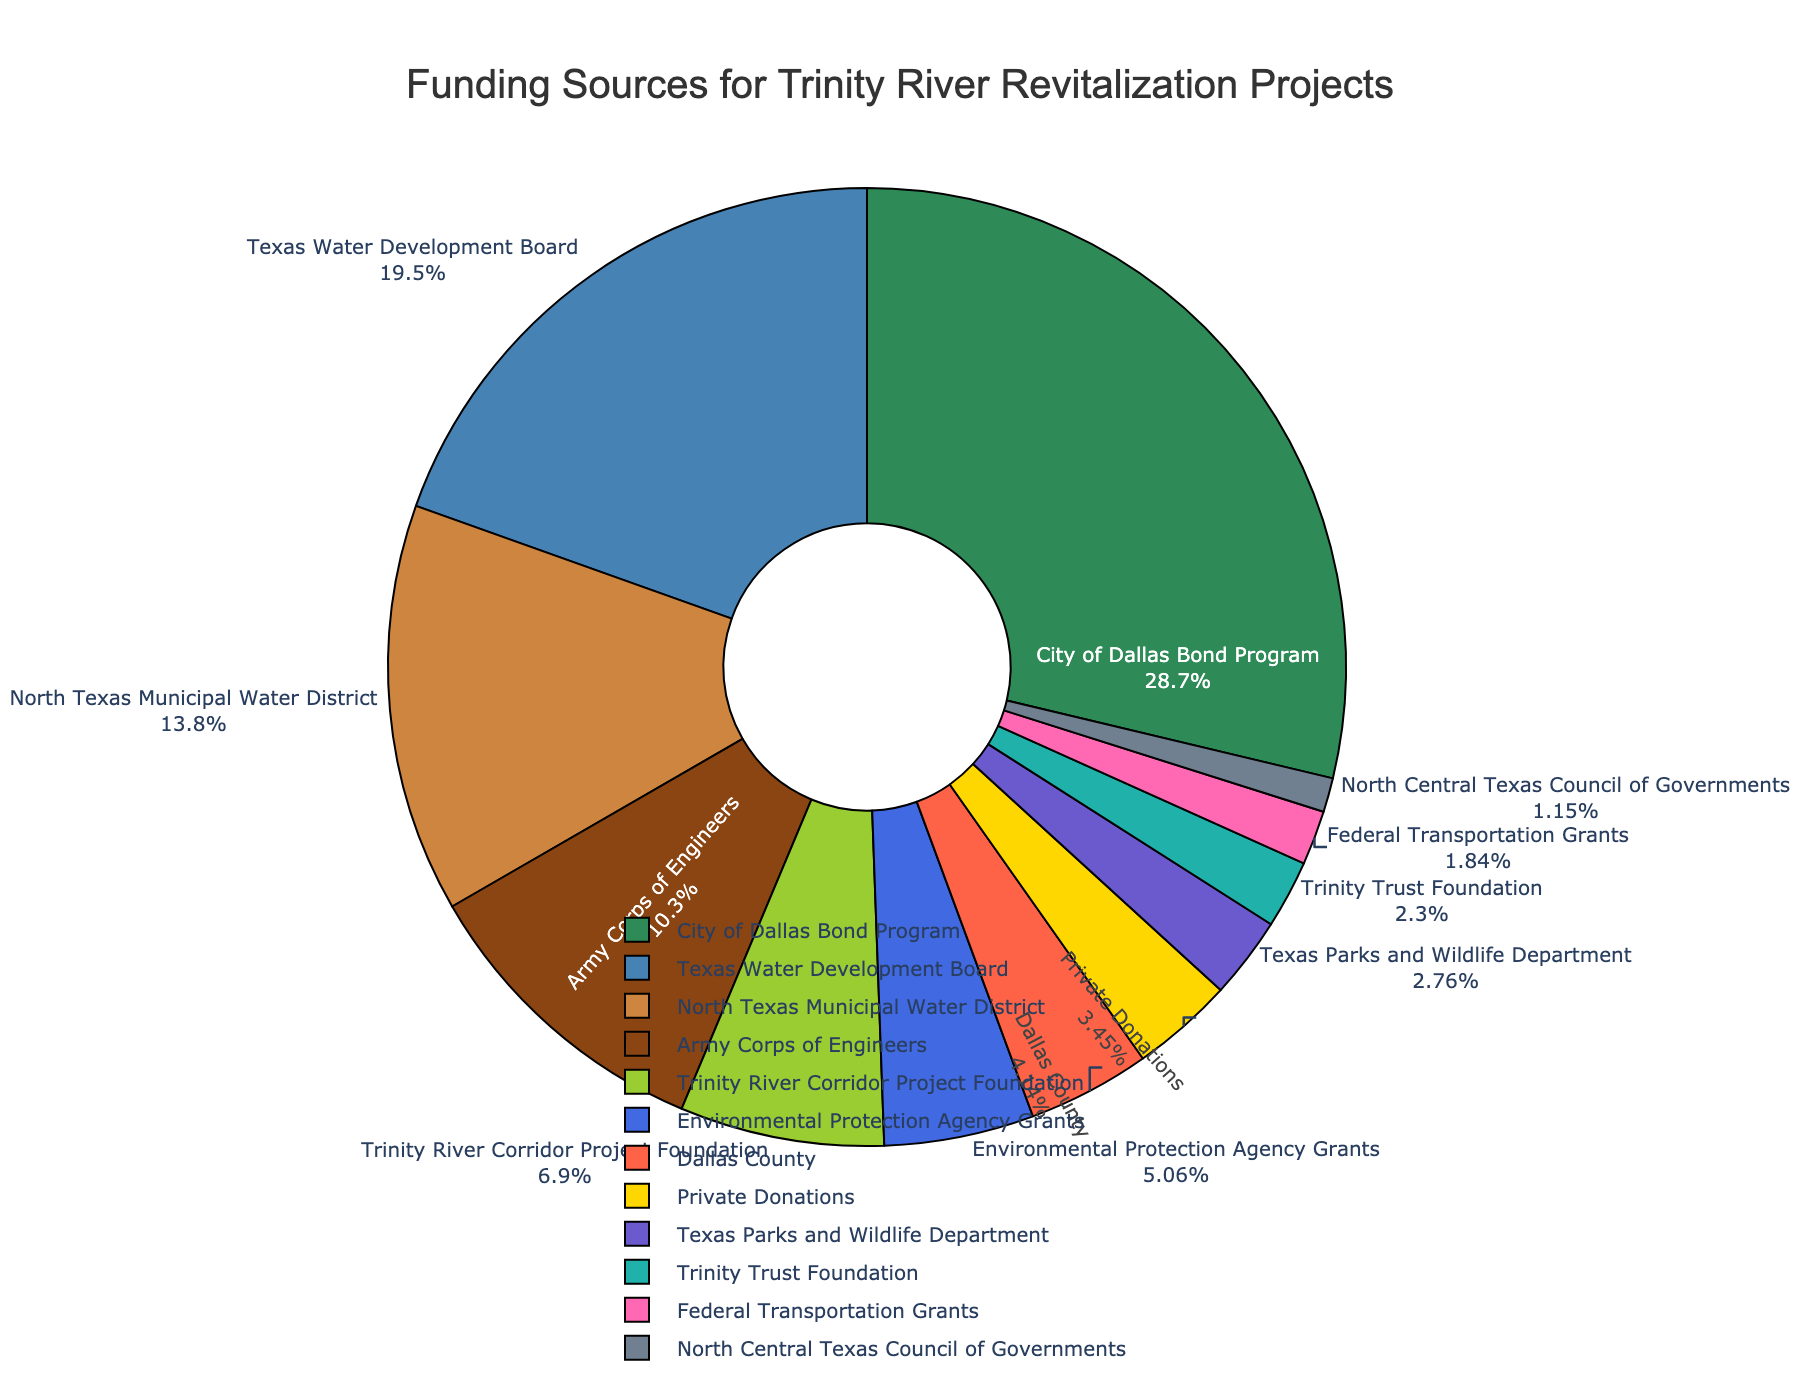Which funding source contributes the most to the Trinity River revitalization projects? The pie chart shows the percentage of funding contributions from various sources. The largest sector corresponds to "City of Dallas Bond Program" which represents the highest contribution.
Answer: City of Dallas Bond Program What is the combined contribution of the top three funding sources? The top three funding sources are "City of Dallas Bond Program", "Texas Water Development Board", and "North Texas Municipal Water District". Adding their contributions: 125 + 85 + 60 = 270 million dollars.
Answer: 270 million dollars Which funding source is associated with the smallest percentage of total funding? The smallest sector in the pie chart corresponds to "North Central Texas Council of Governments".
Answer: North Central Texas Council of Governments How do the contributions from private donations compare to those from government grants? Private donations amount to 15 million. Summing up contributions from government grants: Environmental Protection Agency Grants (22) + Federal Transportation Grants (8) = 30 million. Comparing these values: 30 million (government grants) > 15 million (private donations).
Answer: Government grants contribute more What percentage of the total funding does the Texas Parks and Wildlife Department contribute? The pie chart shows percentages along with labels. Texas Parks and Wildlife Department's sector represents a specific percentage of the total funding.
Answer: Approximately 3.2% What are the combined contributions of non-governmental sources? Non-governmental sources included are "Trinity River Corridor Project Foundation", "Private Donations", and "Trinity Trust Foundation". Summing up their contributions: 30 + 15 + 10 = 55 million dollars.
Answer: 55 million dollars Which funding source represented by a blue color contributes more than 60 million? Identifying the blue-colored sectors and matching them with labels, "Texas Water Development Board" is represented by blue and contributes 85 million, which is more than 60 million.
Answer: Texas Water Development Board Is the contribution from Dallas County larger or smaller than the Army Corps of Engineers' contribution? The chart shows "Dallas County" sector contributing 18 million and "Army Corps of Engineers" sector contributing 45 million. 18 million (Dallas County) < 45 million (Army Corps of Engineers).
Answer: Smaller Which source contributes more: the combined amount from the Trinity River Corridor Project Foundation and the Trinity Trust Foundation or the Texas Water Development Board alone? Adding contributions from Trinity River Corridor Project Foundation (30) and Trinity Trust Foundation (10) gives 40 million while Texas Water Development Board contributes 85 million. Comparing these values: 40 million < 85 million.
Answer: Texas Water Development Board alone How much more does the Environmental Protection Agency contribute compared to the Federal Transportation Grants? Environmental Protection Agency contributes 22 million and Federal Transportation Grants contribute 8 million. The difference is 22 - 8 = 14 million dollars.
Answer: 14 million dollars 